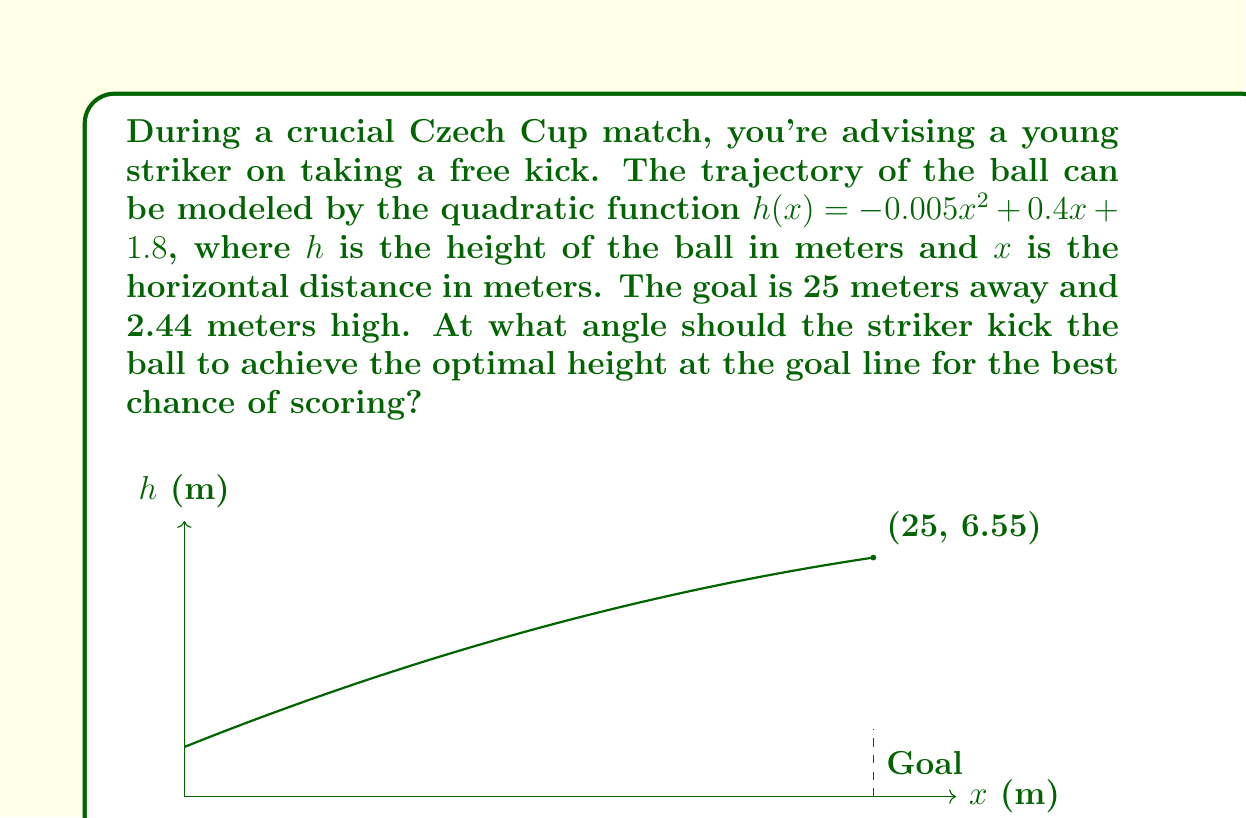Give your solution to this math problem. Let's approach this step-by-step:

1) First, we need to find the height of the ball at the goal line. We can do this by substituting $x=25$ into our function:

   $h(25) = -0.005(25)^2 + 0.4(25) + 1.8$
   $= -0.005(625) + 10 + 1.8$
   $= -3.125 + 10 + 1.8$
   $= 8.675$ meters

2) Now that we know the ball's height at the goal line, we can calculate the angle. We'll use the arctangent function to do this.

3) The angle is formed by the horizontal distance to the goal (25 m) and the vertical distance the ball travels (8.675 m - 1.8 m, as it starts at 1.8 m height).

4) Let's call this angle $\theta$. We can calculate it as follows:

   $\theta = \arctan(\frac{\text{vertical rise}}{\text{horizontal distance}})$

   $\theta = \arctan(\frac{8.675 - 1.8}{25})$

   $\theta = \arctan(\frac{6.875}{25})$

   $\theta = \arctan(0.275)$

5) Converting this to degrees:

   $\theta = \arctan(0.275) * \frac{180}{\pi} \approx 15.37°$

This angle will give the optimal trajectory for the free kick, maximizing the chances of scoring.
Answer: $15.37°$ 